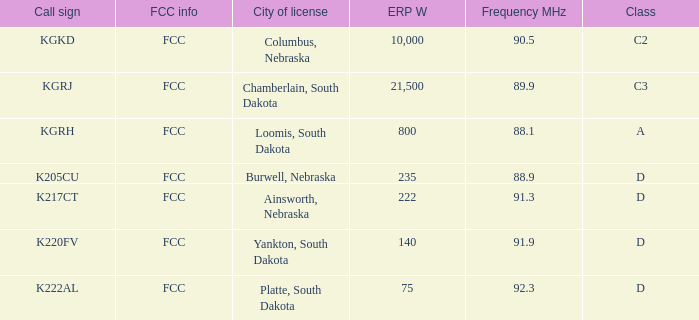What is the call sign with a 222 erp w? K217CT. 